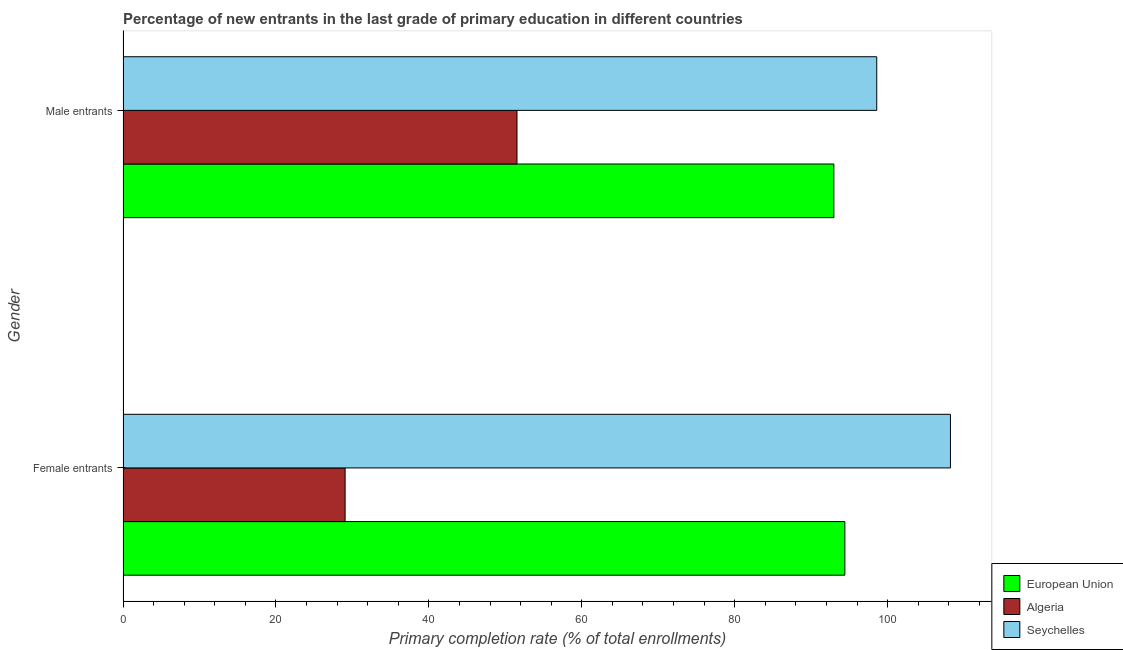Are the number of bars on each tick of the Y-axis equal?
Give a very brief answer. Yes. How many bars are there on the 2nd tick from the top?
Give a very brief answer. 3. How many bars are there on the 1st tick from the bottom?
Offer a terse response. 3. What is the label of the 2nd group of bars from the top?
Ensure brevity in your answer.  Female entrants. What is the primary completion rate of female entrants in European Union?
Keep it short and to the point. 94.4. Across all countries, what is the maximum primary completion rate of male entrants?
Offer a very short reply. 98.57. Across all countries, what is the minimum primary completion rate of female entrants?
Ensure brevity in your answer.  29.05. In which country was the primary completion rate of male entrants maximum?
Offer a terse response. Seychelles. In which country was the primary completion rate of male entrants minimum?
Your response must be concise. Algeria. What is the total primary completion rate of female entrants in the graph?
Provide a succinct answer. 231.65. What is the difference between the primary completion rate of male entrants in Seychelles and that in Algeria?
Offer a terse response. 47.04. What is the difference between the primary completion rate of male entrants in Algeria and the primary completion rate of female entrants in Seychelles?
Give a very brief answer. -56.68. What is the average primary completion rate of female entrants per country?
Your answer should be compact. 77.22. What is the difference between the primary completion rate of male entrants and primary completion rate of female entrants in European Union?
Keep it short and to the point. -1.44. What is the ratio of the primary completion rate of male entrants in Algeria to that in Seychelles?
Your response must be concise. 0.52. Is the primary completion rate of male entrants in Algeria less than that in Seychelles?
Keep it short and to the point. Yes. What does the 2nd bar from the top in Female entrants represents?
Offer a very short reply. Algeria. What does the 3rd bar from the bottom in Female entrants represents?
Offer a terse response. Seychelles. How many bars are there?
Give a very brief answer. 6. Are all the bars in the graph horizontal?
Give a very brief answer. Yes. What is the difference between two consecutive major ticks on the X-axis?
Give a very brief answer. 20. Are the values on the major ticks of X-axis written in scientific E-notation?
Offer a terse response. No. Does the graph contain grids?
Make the answer very short. No. Where does the legend appear in the graph?
Provide a succinct answer. Bottom right. How are the legend labels stacked?
Provide a succinct answer. Vertical. What is the title of the graph?
Give a very brief answer. Percentage of new entrants in the last grade of primary education in different countries. Does "Trinidad and Tobago" appear as one of the legend labels in the graph?
Give a very brief answer. No. What is the label or title of the X-axis?
Your answer should be compact. Primary completion rate (% of total enrollments). What is the label or title of the Y-axis?
Provide a succinct answer. Gender. What is the Primary completion rate (% of total enrollments) of European Union in Female entrants?
Make the answer very short. 94.4. What is the Primary completion rate (% of total enrollments) of Algeria in Female entrants?
Keep it short and to the point. 29.05. What is the Primary completion rate (% of total enrollments) of Seychelles in Female entrants?
Your answer should be compact. 108.21. What is the Primary completion rate (% of total enrollments) in European Union in Male entrants?
Keep it short and to the point. 92.96. What is the Primary completion rate (% of total enrollments) in Algeria in Male entrants?
Your answer should be compact. 51.52. What is the Primary completion rate (% of total enrollments) in Seychelles in Male entrants?
Give a very brief answer. 98.57. Across all Gender, what is the maximum Primary completion rate (% of total enrollments) in European Union?
Make the answer very short. 94.4. Across all Gender, what is the maximum Primary completion rate (% of total enrollments) in Algeria?
Keep it short and to the point. 51.52. Across all Gender, what is the maximum Primary completion rate (% of total enrollments) in Seychelles?
Ensure brevity in your answer.  108.21. Across all Gender, what is the minimum Primary completion rate (% of total enrollments) in European Union?
Offer a terse response. 92.96. Across all Gender, what is the minimum Primary completion rate (% of total enrollments) in Algeria?
Give a very brief answer. 29.05. Across all Gender, what is the minimum Primary completion rate (% of total enrollments) in Seychelles?
Your answer should be compact. 98.57. What is the total Primary completion rate (% of total enrollments) of European Union in the graph?
Give a very brief answer. 187.36. What is the total Primary completion rate (% of total enrollments) of Algeria in the graph?
Make the answer very short. 80.57. What is the total Primary completion rate (% of total enrollments) of Seychelles in the graph?
Ensure brevity in your answer.  206.78. What is the difference between the Primary completion rate (% of total enrollments) in European Union in Female entrants and that in Male entrants?
Your answer should be very brief. 1.44. What is the difference between the Primary completion rate (% of total enrollments) of Algeria in Female entrants and that in Male entrants?
Provide a succinct answer. -22.48. What is the difference between the Primary completion rate (% of total enrollments) of Seychelles in Female entrants and that in Male entrants?
Your response must be concise. 9.64. What is the difference between the Primary completion rate (% of total enrollments) in European Union in Female entrants and the Primary completion rate (% of total enrollments) in Algeria in Male entrants?
Make the answer very short. 42.88. What is the difference between the Primary completion rate (% of total enrollments) of European Union in Female entrants and the Primary completion rate (% of total enrollments) of Seychelles in Male entrants?
Offer a terse response. -4.17. What is the difference between the Primary completion rate (% of total enrollments) of Algeria in Female entrants and the Primary completion rate (% of total enrollments) of Seychelles in Male entrants?
Make the answer very short. -69.52. What is the average Primary completion rate (% of total enrollments) in European Union per Gender?
Your answer should be very brief. 93.68. What is the average Primary completion rate (% of total enrollments) of Algeria per Gender?
Your response must be concise. 40.29. What is the average Primary completion rate (% of total enrollments) in Seychelles per Gender?
Keep it short and to the point. 103.39. What is the difference between the Primary completion rate (% of total enrollments) in European Union and Primary completion rate (% of total enrollments) in Algeria in Female entrants?
Ensure brevity in your answer.  65.35. What is the difference between the Primary completion rate (% of total enrollments) of European Union and Primary completion rate (% of total enrollments) of Seychelles in Female entrants?
Your answer should be compact. -13.81. What is the difference between the Primary completion rate (% of total enrollments) of Algeria and Primary completion rate (% of total enrollments) of Seychelles in Female entrants?
Your response must be concise. -79.16. What is the difference between the Primary completion rate (% of total enrollments) in European Union and Primary completion rate (% of total enrollments) in Algeria in Male entrants?
Provide a succinct answer. 41.44. What is the difference between the Primary completion rate (% of total enrollments) of European Union and Primary completion rate (% of total enrollments) of Seychelles in Male entrants?
Offer a terse response. -5.61. What is the difference between the Primary completion rate (% of total enrollments) in Algeria and Primary completion rate (% of total enrollments) in Seychelles in Male entrants?
Provide a succinct answer. -47.04. What is the ratio of the Primary completion rate (% of total enrollments) in European Union in Female entrants to that in Male entrants?
Ensure brevity in your answer.  1.02. What is the ratio of the Primary completion rate (% of total enrollments) of Algeria in Female entrants to that in Male entrants?
Your answer should be compact. 0.56. What is the ratio of the Primary completion rate (% of total enrollments) of Seychelles in Female entrants to that in Male entrants?
Ensure brevity in your answer.  1.1. What is the difference between the highest and the second highest Primary completion rate (% of total enrollments) in European Union?
Your answer should be compact. 1.44. What is the difference between the highest and the second highest Primary completion rate (% of total enrollments) of Algeria?
Provide a succinct answer. 22.48. What is the difference between the highest and the second highest Primary completion rate (% of total enrollments) of Seychelles?
Provide a succinct answer. 9.64. What is the difference between the highest and the lowest Primary completion rate (% of total enrollments) of European Union?
Make the answer very short. 1.44. What is the difference between the highest and the lowest Primary completion rate (% of total enrollments) of Algeria?
Offer a very short reply. 22.48. What is the difference between the highest and the lowest Primary completion rate (% of total enrollments) of Seychelles?
Your answer should be very brief. 9.64. 